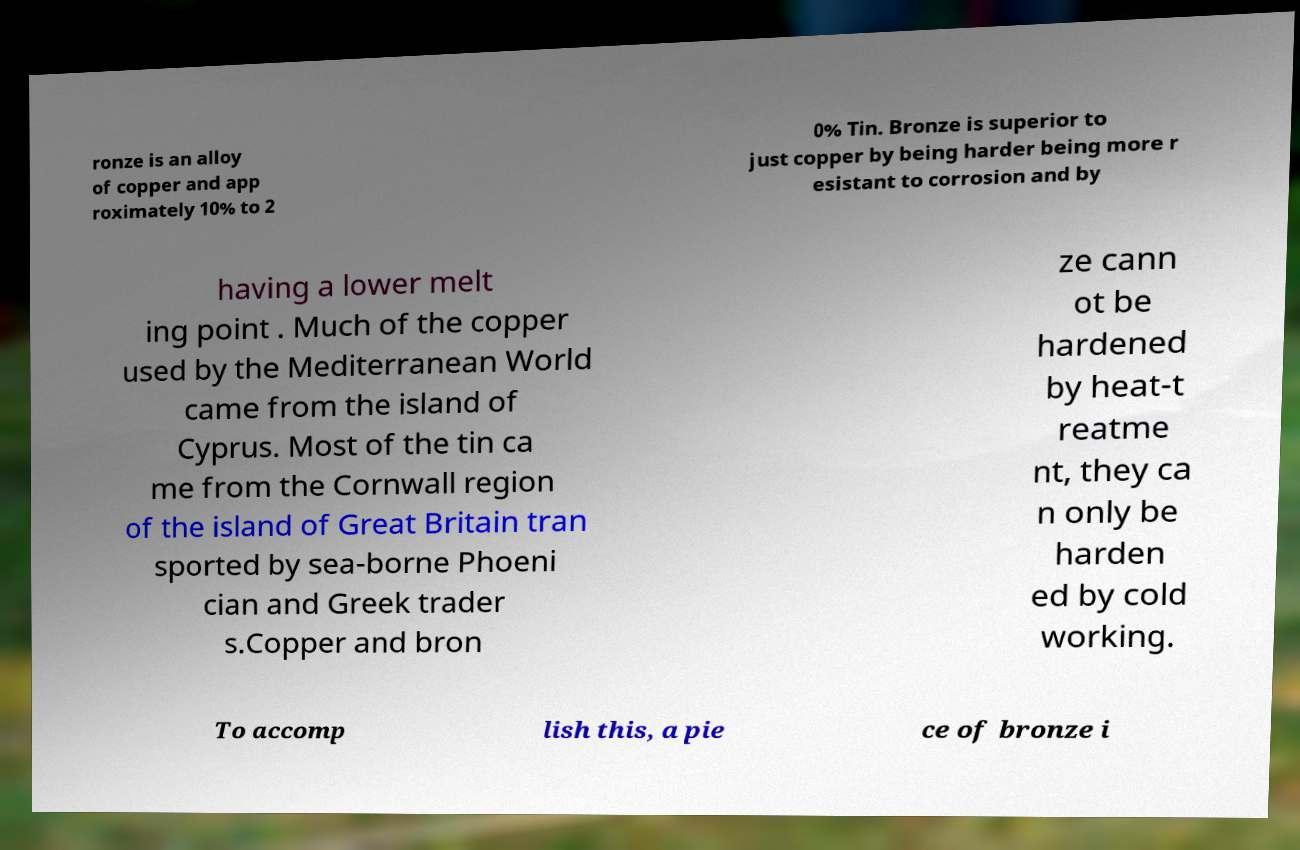Can you read and provide the text displayed in the image?This photo seems to have some interesting text. Can you extract and type it out for me? ronze is an alloy of copper and app roximately 10% to 2 0% Tin. Bronze is superior to just copper by being harder being more r esistant to corrosion and by having a lower melt ing point . Much of the copper used by the Mediterranean World came from the island of Cyprus. Most of the tin ca me from the Cornwall region of the island of Great Britain tran sported by sea-borne Phoeni cian and Greek trader s.Copper and bron ze cann ot be hardened by heat-t reatme nt, they ca n only be harden ed by cold working. To accomp lish this, a pie ce of bronze i 